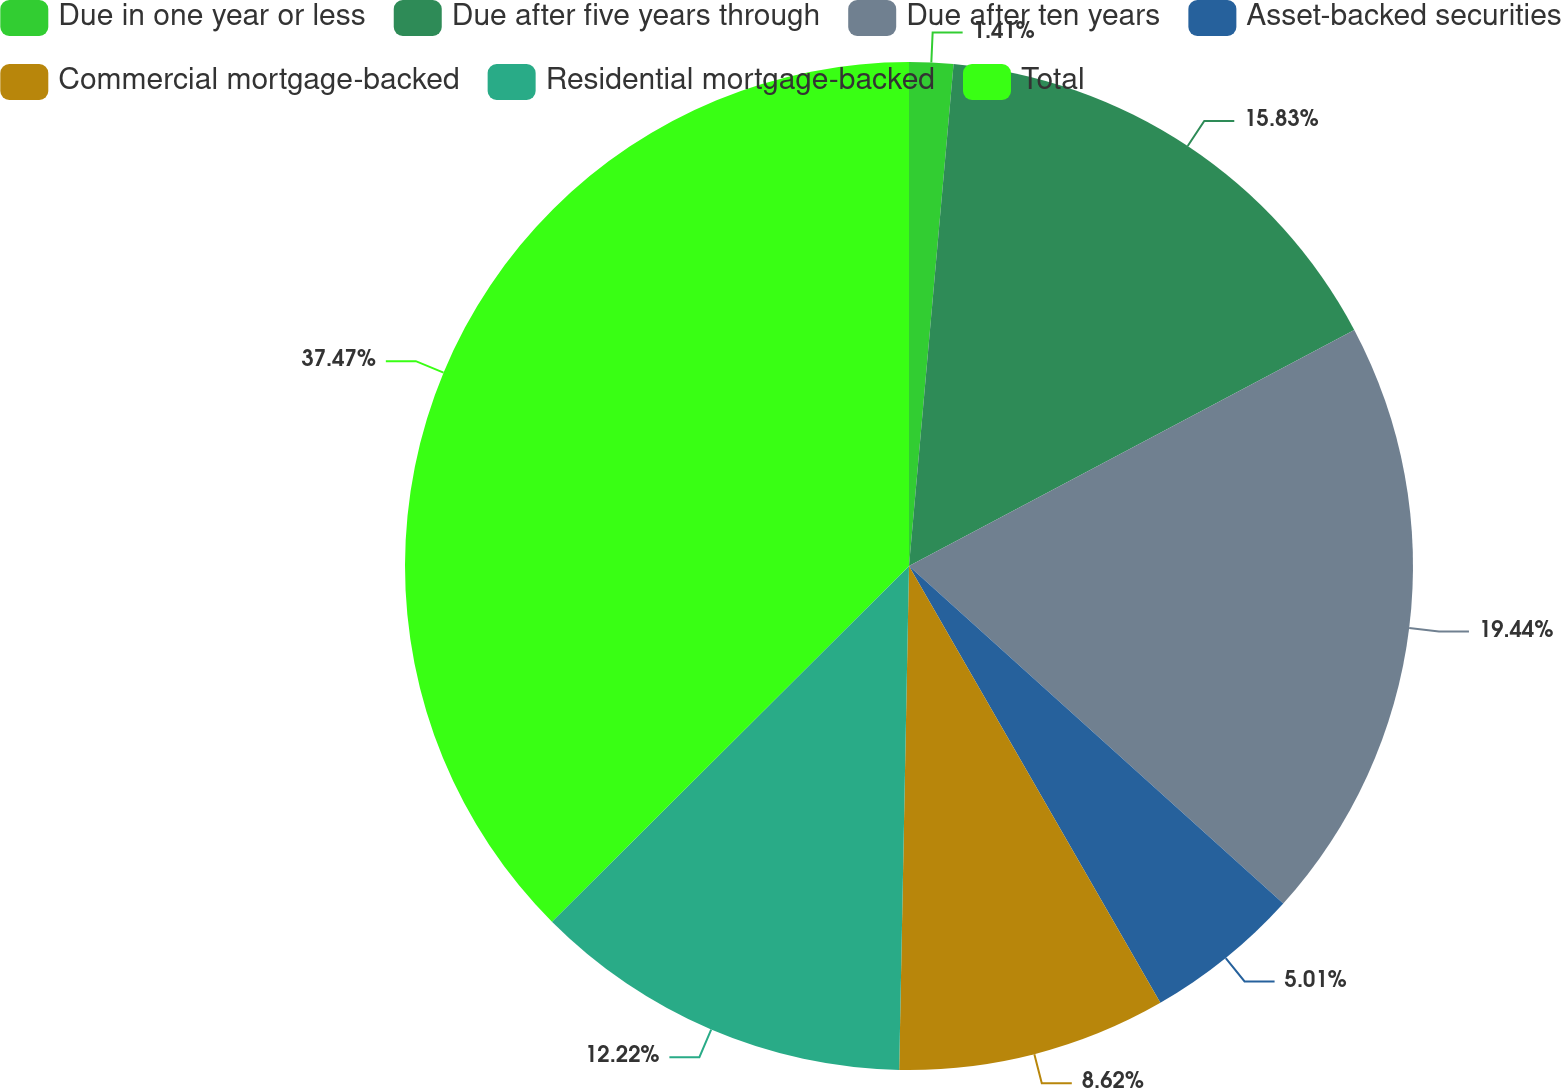Convert chart. <chart><loc_0><loc_0><loc_500><loc_500><pie_chart><fcel>Due in one year or less<fcel>Due after five years through<fcel>Due after ten years<fcel>Asset-backed securities<fcel>Commercial mortgage-backed<fcel>Residential mortgage-backed<fcel>Total<nl><fcel>1.41%<fcel>15.83%<fcel>19.44%<fcel>5.01%<fcel>8.62%<fcel>12.22%<fcel>37.47%<nl></chart> 